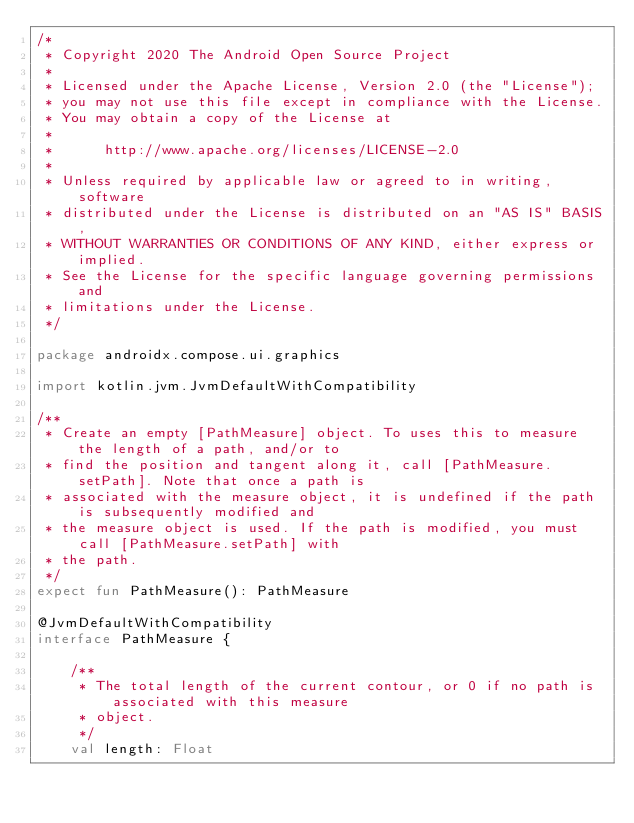<code> <loc_0><loc_0><loc_500><loc_500><_Kotlin_>/*
 * Copyright 2020 The Android Open Source Project
 *
 * Licensed under the Apache License, Version 2.0 (the "License");
 * you may not use this file except in compliance with the License.
 * You may obtain a copy of the License at
 *
 *      http://www.apache.org/licenses/LICENSE-2.0
 *
 * Unless required by applicable law or agreed to in writing, software
 * distributed under the License is distributed on an "AS IS" BASIS,
 * WITHOUT WARRANTIES OR CONDITIONS OF ANY KIND, either express or implied.
 * See the License for the specific language governing permissions and
 * limitations under the License.
 */

package androidx.compose.ui.graphics

import kotlin.jvm.JvmDefaultWithCompatibility

/**
 * Create an empty [PathMeasure] object. To uses this to measure the length of a path, and/or to
 * find the position and tangent along it, call [PathMeasure.setPath]. Note that once a path is
 * associated with the measure object, it is undefined if the path is subsequently modified and
 * the measure object is used. If the path is modified, you must call [PathMeasure.setPath] with
 * the path.
 */
expect fun PathMeasure(): PathMeasure

@JvmDefaultWithCompatibility
interface PathMeasure {

    /**
     * The total length of the current contour, or 0 if no path is associated with this measure
     * object.
     */
    val length: Float
</code> 